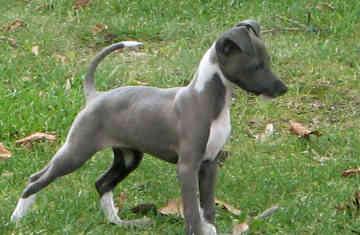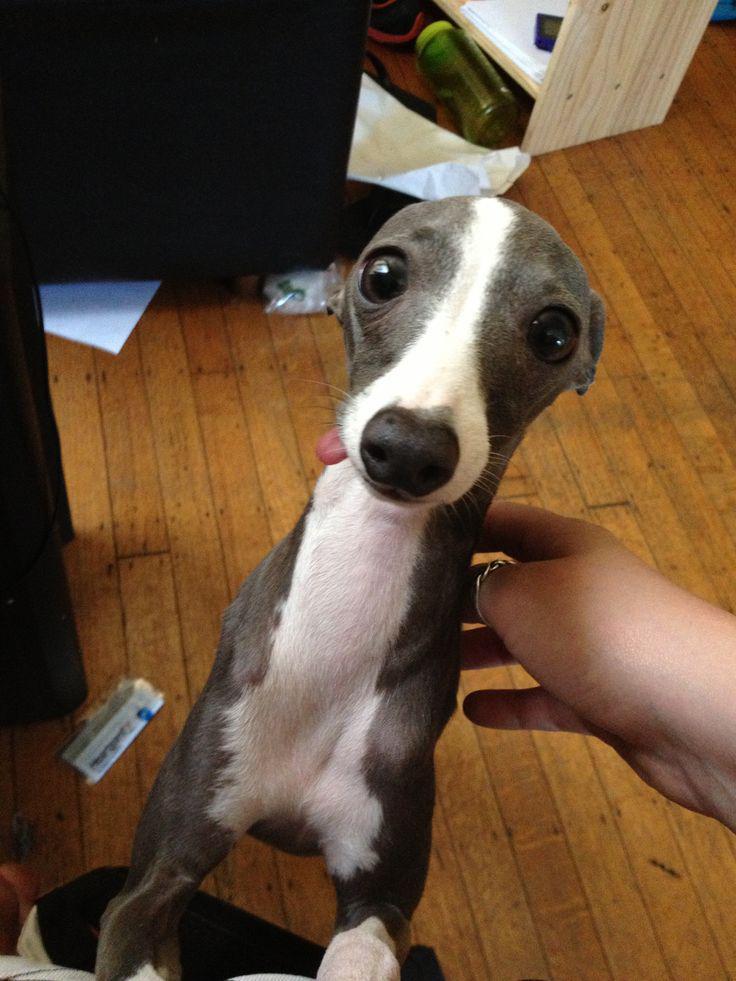The first image is the image on the left, the second image is the image on the right. For the images shown, is this caption "The full body of a dog facing right is on the left image." true? Answer yes or no. Yes. 